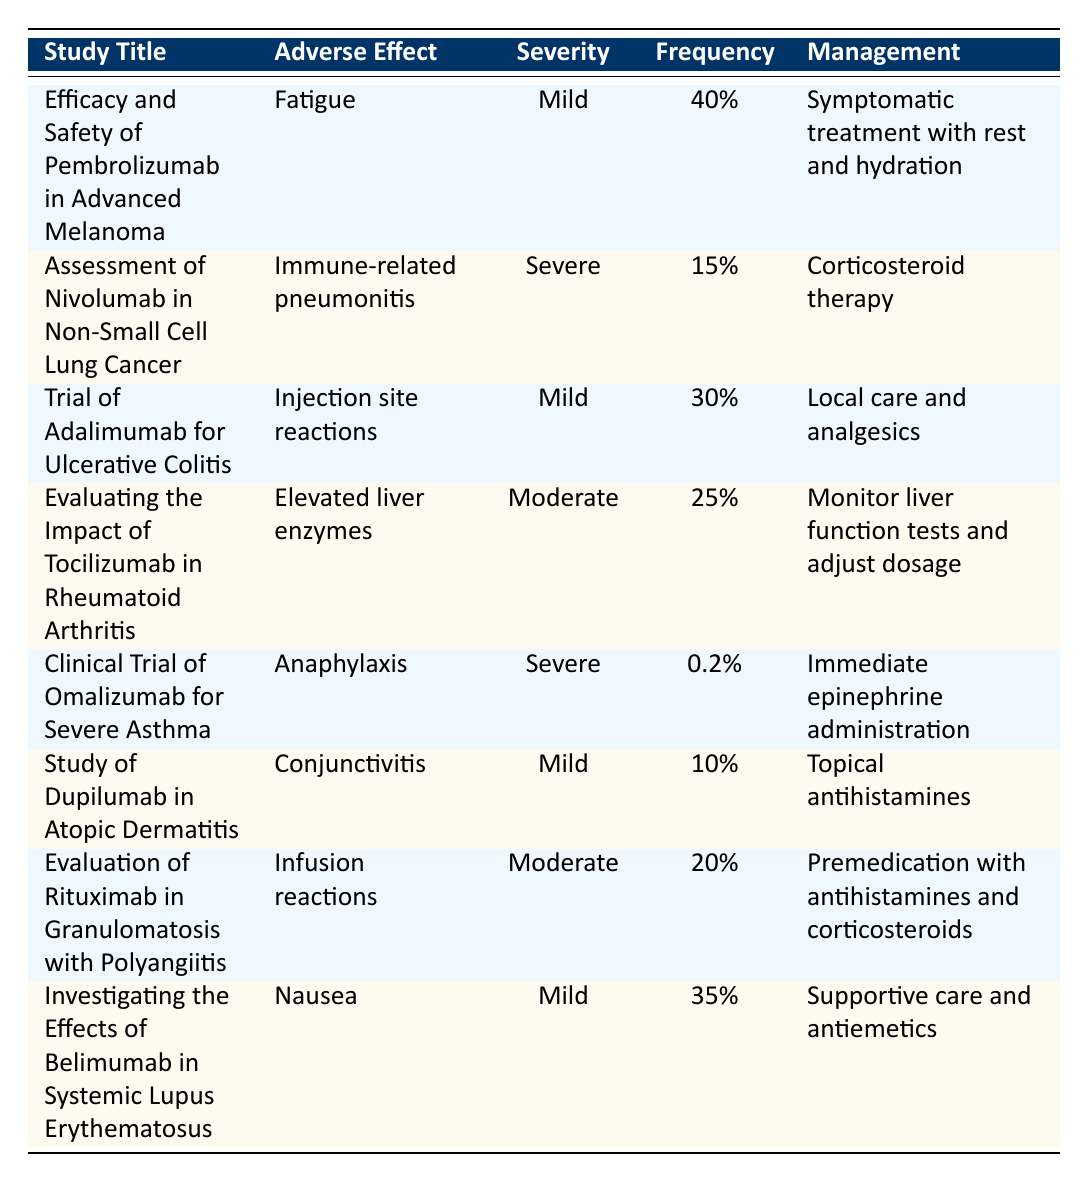What is the most frequently reported adverse effect? To find the most frequently reported adverse effect, we look at the "Frequency" column and identify the highest percentage. "Fatigue" has the highest frequency at 40% from the study "Efficacy and Safety of Pembrolizumab in Advanced Melanoma."
Answer: Fatigue Which adverse effect has the lowest severity rating? By inspecting the "Severity" column for all entries, we see "Anaphylaxis," "Immune-related pneumonitis," and "Fatigue" are categorized as Severe. The others are rated as Mild or Moderate. "Fatigue" is categorized as "Mild," which is the lowest severity rating in the table.
Answer: Fatigue What management is recommended for elevated liver enzymes? The management for elevated liver enzymes as noted in the study "Evaluating the Impact of Tocilizumab in Rheumatoid Arthritis" is to monitor liver function tests and adjust dosage.
Answer: Monitor liver function tests and adjust dosage How many adverse effects are classified as Severe? We count the entries in the "Severity" column that are marked as "Severe." There are 2 instances of Severe effects: "Immune-related pneumonitis" and "Anaphylaxis."
Answer: 2 What is the frequency difference between the most common and the least common adverse effects? The most common adverse effect is "Fatigue" at 40%, and the least common is "Anaphylaxis" at 0.2%. To find the difference, we subtract the least from the most: 40% - 0.2% = 39.8%.
Answer: 39.8% Is "Nausea" considered a severe adverse effect? "Nausea" is listed with a severity of "Mild," according to the study "Investigating the Effects of Belimumab in Systemic Lupus Erythematosus," therefore it is not considered a severe adverse effect.
Answer: No What percentage of patients reported injection site reactions compared to those who reported conjunctivitis? Injection site reactions have a frequency of 30%, while conjunctivitis is reported at 10%. The difference is 30% - 10% = 20%. Therefore, injection site reactions are 20% more frequent than conjunctivitis.
Answer: 20% Which management is common for both "Infusion reactions" and "Injection site reactions"? Examining management strategies shows that "Injected site reactions" require local care and analgesics, while "Infusion reactions" require premedication with antihistamines and corticosteroids. There seems to be no common management strategy.
Answer: No common management strategy What percentage of studies reported adverse effects with moderate severity? Inspecting the "Severity" column reveals two adverse effects rated as Moderate: "Elevated liver enzymes" and "Infusion reactions," out of 8 total studies. To calculate the percentage, (2/8) * 100% = 25%.
Answer: 25% 